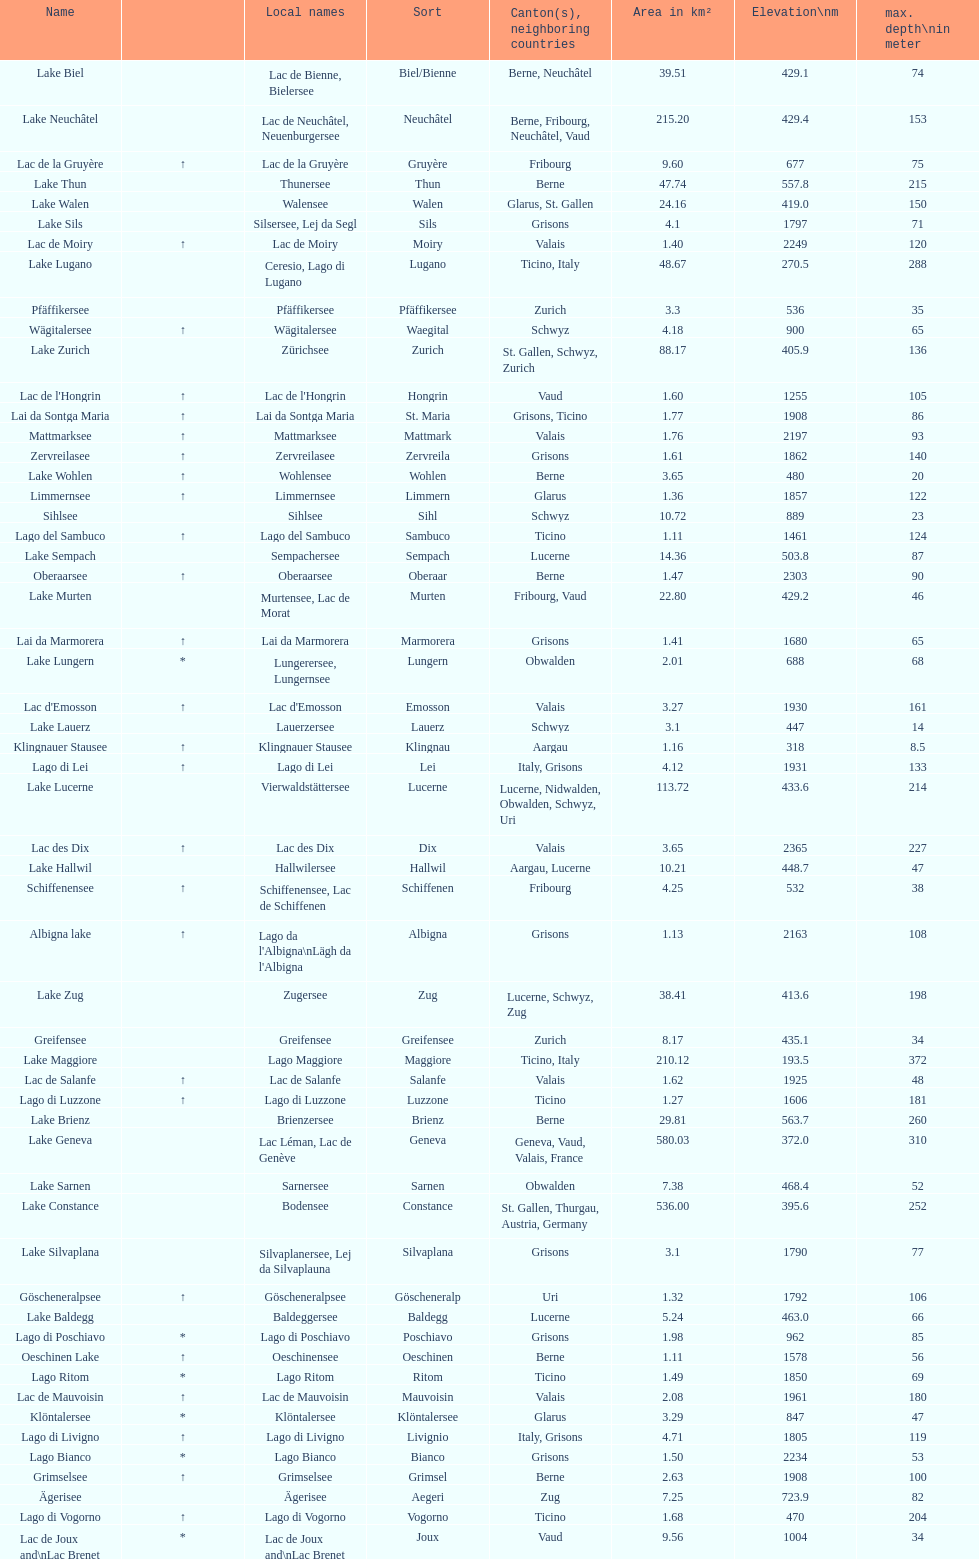Which lake is located at an elevation above 193m? Lake Maggiore. 